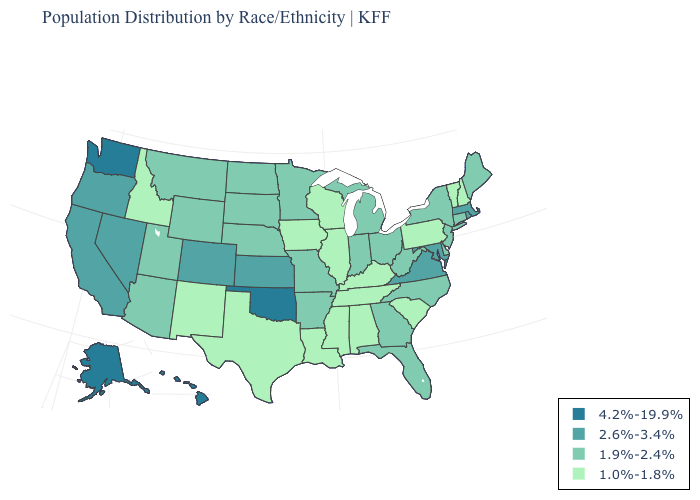How many symbols are there in the legend?
Answer briefly. 4. What is the value of Alabama?
Write a very short answer. 1.0%-1.8%. Name the states that have a value in the range 1.9%-2.4%?
Keep it brief. Arizona, Arkansas, Connecticut, Delaware, Florida, Georgia, Indiana, Maine, Michigan, Minnesota, Missouri, Montana, Nebraska, New Jersey, New York, North Carolina, North Dakota, Ohio, South Dakota, Utah, West Virginia, Wyoming. What is the lowest value in states that border Utah?
Quick response, please. 1.0%-1.8%. What is the lowest value in the MidWest?
Concise answer only. 1.0%-1.8%. Which states hav the highest value in the South?
Quick response, please. Oklahoma. What is the value of Nevada?
Concise answer only. 2.6%-3.4%. Does the map have missing data?
Write a very short answer. No. Which states have the lowest value in the West?
Answer briefly. Idaho, New Mexico. What is the lowest value in states that border Massachusetts?
Keep it brief. 1.0%-1.8%. Does Alabama have the highest value in the South?
Give a very brief answer. No. Among the states that border Maine , which have the highest value?
Concise answer only. New Hampshire. Does the first symbol in the legend represent the smallest category?
Be succinct. No. What is the lowest value in states that border Louisiana?
Concise answer only. 1.0%-1.8%. How many symbols are there in the legend?
Short answer required. 4. 